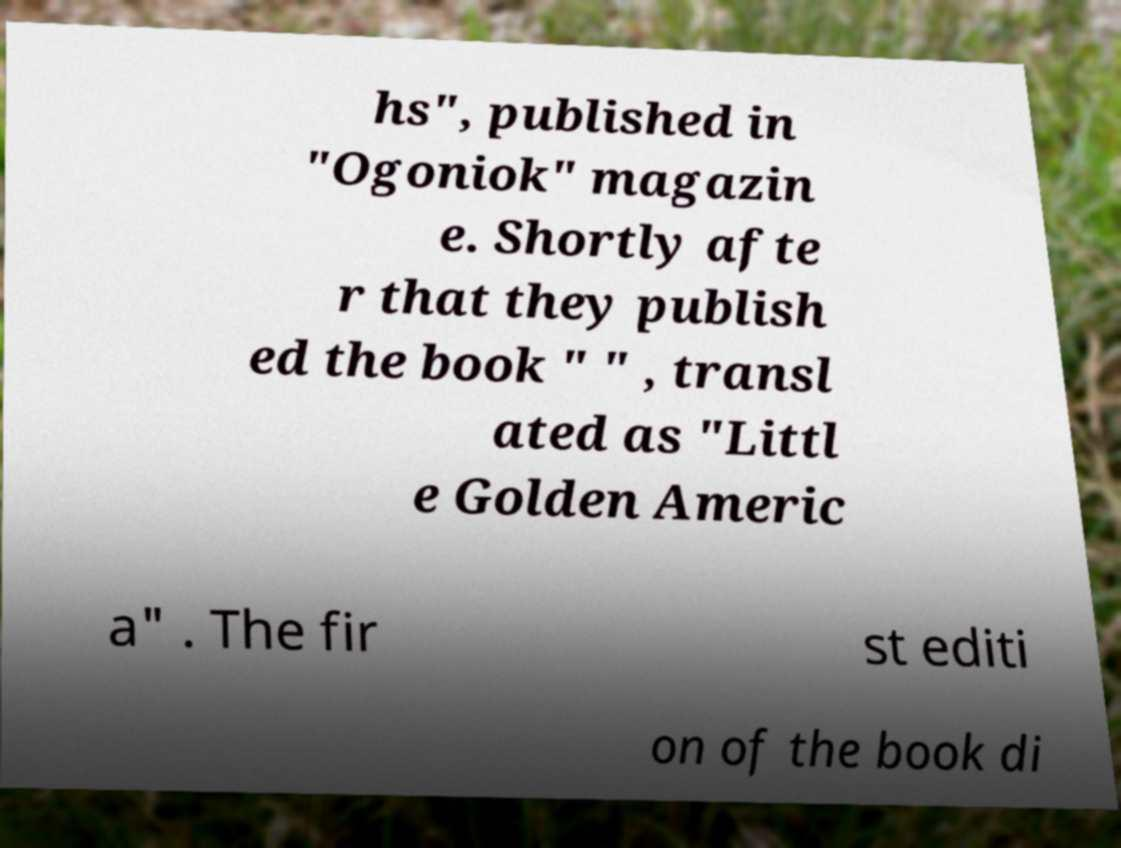Please read and relay the text visible in this image. What does it say? hs", published in "Ogoniok" magazin e. Shortly afte r that they publish ed the book " " , transl ated as "Littl e Golden Americ a" . The fir st editi on of the book di 